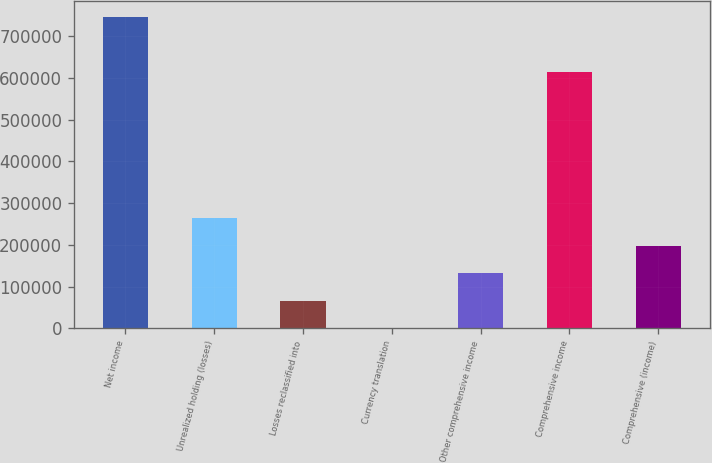Convert chart to OTSL. <chart><loc_0><loc_0><loc_500><loc_500><bar_chart><fcel>Net income<fcel>Unrealized holding (losses)<fcel>Losses reclassified into<fcel>Currency translation<fcel>Other comprehensive income<fcel>Comprehensive income<fcel>Comprehensive (income)<nl><fcel>746591<fcel>263804<fcel>66365.1<fcel>552<fcel>132178<fcel>614965<fcel>197991<nl></chart> 